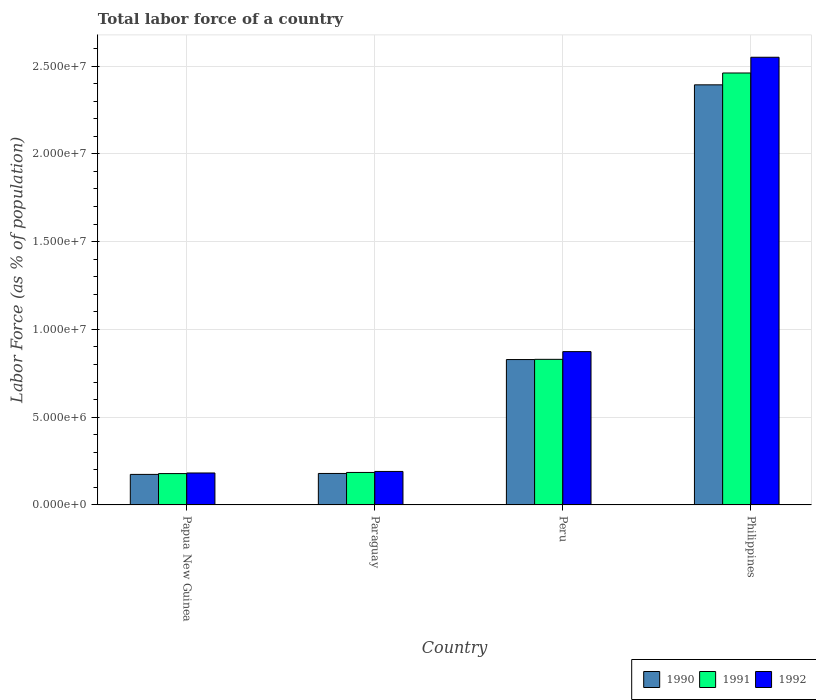How many different coloured bars are there?
Provide a short and direct response. 3. How many groups of bars are there?
Your answer should be very brief. 4. Are the number of bars per tick equal to the number of legend labels?
Your response must be concise. Yes. How many bars are there on the 3rd tick from the left?
Offer a terse response. 3. How many bars are there on the 2nd tick from the right?
Offer a terse response. 3. What is the label of the 3rd group of bars from the left?
Offer a very short reply. Peru. In how many cases, is the number of bars for a given country not equal to the number of legend labels?
Your response must be concise. 0. What is the percentage of labor force in 1990 in Papua New Guinea?
Provide a succinct answer. 1.74e+06. Across all countries, what is the maximum percentage of labor force in 1992?
Provide a short and direct response. 2.55e+07. Across all countries, what is the minimum percentage of labor force in 1992?
Keep it short and to the point. 1.82e+06. In which country was the percentage of labor force in 1990 maximum?
Your response must be concise. Philippines. In which country was the percentage of labor force in 1991 minimum?
Keep it short and to the point. Papua New Guinea. What is the total percentage of labor force in 1992 in the graph?
Provide a short and direct response. 3.80e+07. What is the difference between the percentage of labor force in 1990 in Paraguay and that in Peru?
Provide a succinct answer. -6.49e+06. What is the difference between the percentage of labor force in 1990 in Philippines and the percentage of labor force in 1991 in Peru?
Provide a succinct answer. 1.56e+07. What is the average percentage of labor force in 1991 per country?
Provide a short and direct response. 9.13e+06. What is the difference between the percentage of labor force of/in 1991 and percentage of labor force of/in 1990 in Papua New Guinea?
Your response must be concise. 4.64e+04. What is the ratio of the percentage of labor force in 1990 in Papua New Guinea to that in Peru?
Provide a succinct answer. 0.21. Is the percentage of labor force in 1991 in Peru less than that in Philippines?
Give a very brief answer. Yes. Is the difference between the percentage of labor force in 1991 in Peru and Philippines greater than the difference between the percentage of labor force in 1990 in Peru and Philippines?
Provide a short and direct response. No. What is the difference between the highest and the second highest percentage of labor force in 1990?
Give a very brief answer. -1.56e+07. What is the difference between the highest and the lowest percentage of labor force in 1992?
Your answer should be compact. 2.37e+07. In how many countries, is the percentage of labor force in 1992 greater than the average percentage of labor force in 1992 taken over all countries?
Your response must be concise. 1. What does the 3rd bar from the left in Papua New Guinea represents?
Offer a terse response. 1992. How many countries are there in the graph?
Ensure brevity in your answer.  4. Does the graph contain any zero values?
Your response must be concise. No. Does the graph contain grids?
Provide a succinct answer. Yes. What is the title of the graph?
Your response must be concise. Total labor force of a country. What is the label or title of the X-axis?
Provide a succinct answer. Country. What is the label or title of the Y-axis?
Give a very brief answer. Labor Force (as % of population). What is the Labor Force (as % of population) of 1990 in Papua New Guinea?
Provide a short and direct response. 1.74e+06. What is the Labor Force (as % of population) of 1991 in Papua New Guinea?
Your answer should be compact. 1.79e+06. What is the Labor Force (as % of population) of 1992 in Papua New Guinea?
Keep it short and to the point. 1.82e+06. What is the Labor Force (as % of population) of 1990 in Paraguay?
Give a very brief answer. 1.79e+06. What is the Labor Force (as % of population) in 1991 in Paraguay?
Your response must be concise. 1.85e+06. What is the Labor Force (as % of population) of 1992 in Paraguay?
Make the answer very short. 1.91e+06. What is the Labor Force (as % of population) in 1990 in Peru?
Give a very brief answer. 8.28e+06. What is the Labor Force (as % of population) of 1991 in Peru?
Offer a terse response. 8.29e+06. What is the Labor Force (as % of population) of 1992 in Peru?
Ensure brevity in your answer.  8.73e+06. What is the Labor Force (as % of population) of 1990 in Philippines?
Your response must be concise. 2.39e+07. What is the Labor Force (as % of population) of 1991 in Philippines?
Your answer should be compact. 2.46e+07. What is the Labor Force (as % of population) of 1992 in Philippines?
Offer a terse response. 2.55e+07. Across all countries, what is the maximum Labor Force (as % of population) of 1990?
Your answer should be very brief. 2.39e+07. Across all countries, what is the maximum Labor Force (as % of population) of 1991?
Make the answer very short. 2.46e+07. Across all countries, what is the maximum Labor Force (as % of population) of 1992?
Offer a terse response. 2.55e+07. Across all countries, what is the minimum Labor Force (as % of population) in 1990?
Provide a succinct answer. 1.74e+06. Across all countries, what is the minimum Labor Force (as % of population) in 1991?
Your answer should be very brief. 1.79e+06. Across all countries, what is the minimum Labor Force (as % of population) of 1992?
Your response must be concise. 1.82e+06. What is the total Labor Force (as % of population) of 1990 in the graph?
Give a very brief answer. 3.57e+07. What is the total Labor Force (as % of population) in 1991 in the graph?
Your response must be concise. 3.65e+07. What is the total Labor Force (as % of population) in 1992 in the graph?
Give a very brief answer. 3.80e+07. What is the difference between the Labor Force (as % of population) of 1990 in Papua New Guinea and that in Paraguay?
Ensure brevity in your answer.  -5.31e+04. What is the difference between the Labor Force (as % of population) of 1991 in Papua New Guinea and that in Paraguay?
Provide a succinct answer. -6.46e+04. What is the difference between the Labor Force (as % of population) of 1992 in Papua New Guinea and that in Paraguay?
Your answer should be compact. -8.69e+04. What is the difference between the Labor Force (as % of population) in 1990 in Papua New Guinea and that in Peru?
Make the answer very short. -6.54e+06. What is the difference between the Labor Force (as % of population) in 1991 in Papua New Guinea and that in Peru?
Offer a terse response. -6.51e+06. What is the difference between the Labor Force (as % of population) of 1992 in Papua New Guinea and that in Peru?
Make the answer very short. -6.91e+06. What is the difference between the Labor Force (as % of population) in 1990 in Papua New Guinea and that in Philippines?
Give a very brief answer. -2.22e+07. What is the difference between the Labor Force (as % of population) in 1991 in Papua New Guinea and that in Philippines?
Give a very brief answer. -2.28e+07. What is the difference between the Labor Force (as % of population) in 1992 in Papua New Guinea and that in Philippines?
Make the answer very short. -2.37e+07. What is the difference between the Labor Force (as % of population) of 1990 in Paraguay and that in Peru?
Provide a short and direct response. -6.49e+06. What is the difference between the Labor Force (as % of population) in 1991 in Paraguay and that in Peru?
Your answer should be very brief. -6.44e+06. What is the difference between the Labor Force (as % of population) in 1992 in Paraguay and that in Peru?
Offer a very short reply. -6.83e+06. What is the difference between the Labor Force (as % of population) of 1990 in Paraguay and that in Philippines?
Your response must be concise. -2.21e+07. What is the difference between the Labor Force (as % of population) in 1991 in Paraguay and that in Philippines?
Keep it short and to the point. -2.28e+07. What is the difference between the Labor Force (as % of population) of 1992 in Paraguay and that in Philippines?
Ensure brevity in your answer.  -2.36e+07. What is the difference between the Labor Force (as % of population) in 1990 in Peru and that in Philippines?
Your answer should be compact. -1.56e+07. What is the difference between the Labor Force (as % of population) in 1991 in Peru and that in Philippines?
Offer a terse response. -1.63e+07. What is the difference between the Labor Force (as % of population) in 1992 in Peru and that in Philippines?
Offer a terse response. -1.68e+07. What is the difference between the Labor Force (as % of population) in 1990 in Papua New Guinea and the Labor Force (as % of population) in 1991 in Paraguay?
Make the answer very short. -1.11e+05. What is the difference between the Labor Force (as % of population) in 1990 in Papua New Guinea and the Labor Force (as % of population) in 1992 in Paraguay?
Provide a short and direct response. -1.68e+05. What is the difference between the Labor Force (as % of population) of 1991 in Papua New Guinea and the Labor Force (as % of population) of 1992 in Paraguay?
Provide a short and direct response. -1.21e+05. What is the difference between the Labor Force (as % of population) of 1990 in Papua New Guinea and the Labor Force (as % of population) of 1991 in Peru?
Make the answer very short. -6.55e+06. What is the difference between the Labor Force (as % of population) in 1990 in Papua New Guinea and the Labor Force (as % of population) in 1992 in Peru?
Offer a terse response. -6.99e+06. What is the difference between the Labor Force (as % of population) of 1991 in Papua New Guinea and the Labor Force (as % of population) of 1992 in Peru?
Your response must be concise. -6.95e+06. What is the difference between the Labor Force (as % of population) in 1990 in Papua New Guinea and the Labor Force (as % of population) in 1991 in Philippines?
Ensure brevity in your answer.  -2.29e+07. What is the difference between the Labor Force (as % of population) in 1990 in Papua New Guinea and the Labor Force (as % of population) in 1992 in Philippines?
Your answer should be very brief. -2.38e+07. What is the difference between the Labor Force (as % of population) of 1991 in Papua New Guinea and the Labor Force (as % of population) of 1992 in Philippines?
Your response must be concise. -2.37e+07. What is the difference between the Labor Force (as % of population) in 1990 in Paraguay and the Labor Force (as % of population) in 1991 in Peru?
Provide a short and direct response. -6.50e+06. What is the difference between the Labor Force (as % of population) of 1990 in Paraguay and the Labor Force (as % of population) of 1992 in Peru?
Offer a very short reply. -6.94e+06. What is the difference between the Labor Force (as % of population) in 1991 in Paraguay and the Labor Force (as % of population) in 1992 in Peru?
Keep it short and to the point. -6.88e+06. What is the difference between the Labor Force (as % of population) in 1990 in Paraguay and the Labor Force (as % of population) in 1991 in Philippines?
Offer a terse response. -2.28e+07. What is the difference between the Labor Force (as % of population) of 1990 in Paraguay and the Labor Force (as % of population) of 1992 in Philippines?
Provide a short and direct response. -2.37e+07. What is the difference between the Labor Force (as % of population) in 1991 in Paraguay and the Labor Force (as % of population) in 1992 in Philippines?
Keep it short and to the point. -2.36e+07. What is the difference between the Labor Force (as % of population) in 1990 in Peru and the Labor Force (as % of population) in 1991 in Philippines?
Your answer should be very brief. -1.63e+07. What is the difference between the Labor Force (as % of population) in 1990 in Peru and the Labor Force (as % of population) in 1992 in Philippines?
Provide a short and direct response. -1.72e+07. What is the difference between the Labor Force (as % of population) of 1991 in Peru and the Labor Force (as % of population) of 1992 in Philippines?
Offer a terse response. -1.72e+07. What is the average Labor Force (as % of population) of 1990 per country?
Your answer should be very brief. 8.93e+06. What is the average Labor Force (as % of population) in 1991 per country?
Your answer should be very brief. 9.13e+06. What is the average Labor Force (as % of population) in 1992 per country?
Offer a terse response. 9.49e+06. What is the difference between the Labor Force (as % of population) in 1990 and Labor Force (as % of population) in 1991 in Papua New Guinea?
Your answer should be compact. -4.64e+04. What is the difference between the Labor Force (as % of population) of 1990 and Labor Force (as % of population) of 1992 in Papua New Guinea?
Make the answer very short. -8.10e+04. What is the difference between the Labor Force (as % of population) in 1991 and Labor Force (as % of population) in 1992 in Papua New Guinea?
Your answer should be very brief. -3.46e+04. What is the difference between the Labor Force (as % of population) of 1990 and Labor Force (as % of population) of 1991 in Paraguay?
Provide a short and direct response. -5.79e+04. What is the difference between the Labor Force (as % of population) of 1990 and Labor Force (as % of population) of 1992 in Paraguay?
Provide a short and direct response. -1.15e+05. What is the difference between the Labor Force (as % of population) of 1991 and Labor Force (as % of population) of 1992 in Paraguay?
Your response must be concise. -5.69e+04. What is the difference between the Labor Force (as % of population) of 1990 and Labor Force (as % of population) of 1991 in Peru?
Offer a terse response. -1.25e+04. What is the difference between the Labor Force (as % of population) in 1990 and Labor Force (as % of population) in 1992 in Peru?
Provide a short and direct response. -4.52e+05. What is the difference between the Labor Force (as % of population) of 1991 and Labor Force (as % of population) of 1992 in Peru?
Keep it short and to the point. -4.39e+05. What is the difference between the Labor Force (as % of population) in 1990 and Labor Force (as % of population) in 1991 in Philippines?
Ensure brevity in your answer.  -6.75e+05. What is the difference between the Labor Force (as % of population) in 1990 and Labor Force (as % of population) in 1992 in Philippines?
Give a very brief answer. -1.57e+06. What is the difference between the Labor Force (as % of population) in 1991 and Labor Force (as % of population) in 1992 in Philippines?
Your answer should be compact. -8.96e+05. What is the ratio of the Labor Force (as % of population) of 1990 in Papua New Guinea to that in Paraguay?
Provide a short and direct response. 0.97. What is the ratio of the Labor Force (as % of population) of 1991 in Papua New Guinea to that in Paraguay?
Provide a succinct answer. 0.97. What is the ratio of the Labor Force (as % of population) of 1992 in Papua New Guinea to that in Paraguay?
Ensure brevity in your answer.  0.95. What is the ratio of the Labor Force (as % of population) in 1990 in Papua New Guinea to that in Peru?
Your response must be concise. 0.21. What is the ratio of the Labor Force (as % of population) in 1991 in Papua New Guinea to that in Peru?
Your answer should be compact. 0.22. What is the ratio of the Labor Force (as % of population) of 1992 in Papua New Guinea to that in Peru?
Offer a terse response. 0.21. What is the ratio of the Labor Force (as % of population) of 1990 in Papua New Guinea to that in Philippines?
Give a very brief answer. 0.07. What is the ratio of the Labor Force (as % of population) of 1991 in Papua New Guinea to that in Philippines?
Offer a very short reply. 0.07. What is the ratio of the Labor Force (as % of population) in 1992 in Papua New Guinea to that in Philippines?
Keep it short and to the point. 0.07. What is the ratio of the Labor Force (as % of population) in 1990 in Paraguay to that in Peru?
Keep it short and to the point. 0.22. What is the ratio of the Labor Force (as % of population) of 1991 in Paraguay to that in Peru?
Your response must be concise. 0.22. What is the ratio of the Labor Force (as % of population) of 1992 in Paraguay to that in Peru?
Give a very brief answer. 0.22. What is the ratio of the Labor Force (as % of population) of 1990 in Paraguay to that in Philippines?
Offer a terse response. 0.07. What is the ratio of the Labor Force (as % of population) in 1991 in Paraguay to that in Philippines?
Keep it short and to the point. 0.08. What is the ratio of the Labor Force (as % of population) of 1992 in Paraguay to that in Philippines?
Give a very brief answer. 0.07. What is the ratio of the Labor Force (as % of population) of 1990 in Peru to that in Philippines?
Ensure brevity in your answer.  0.35. What is the ratio of the Labor Force (as % of population) of 1991 in Peru to that in Philippines?
Ensure brevity in your answer.  0.34. What is the ratio of the Labor Force (as % of population) in 1992 in Peru to that in Philippines?
Keep it short and to the point. 0.34. What is the difference between the highest and the second highest Labor Force (as % of population) in 1990?
Ensure brevity in your answer.  1.56e+07. What is the difference between the highest and the second highest Labor Force (as % of population) in 1991?
Your answer should be very brief. 1.63e+07. What is the difference between the highest and the second highest Labor Force (as % of population) of 1992?
Offer a terse response. 1.68e+07. What is the difference between the highest and the lowest Labor Force (as % of population) in 1990?
Offer a very short reply. 2.22e+07. What is the difference between the highest and the lowest Labor Force (as % of population) of 1991?
Ensure brevity in your answer.  2.28e+07. What is the difference between the highest and the lowest Labor Force (as % of population) in 1992?
Make the answer very short. 2.37e+07. 